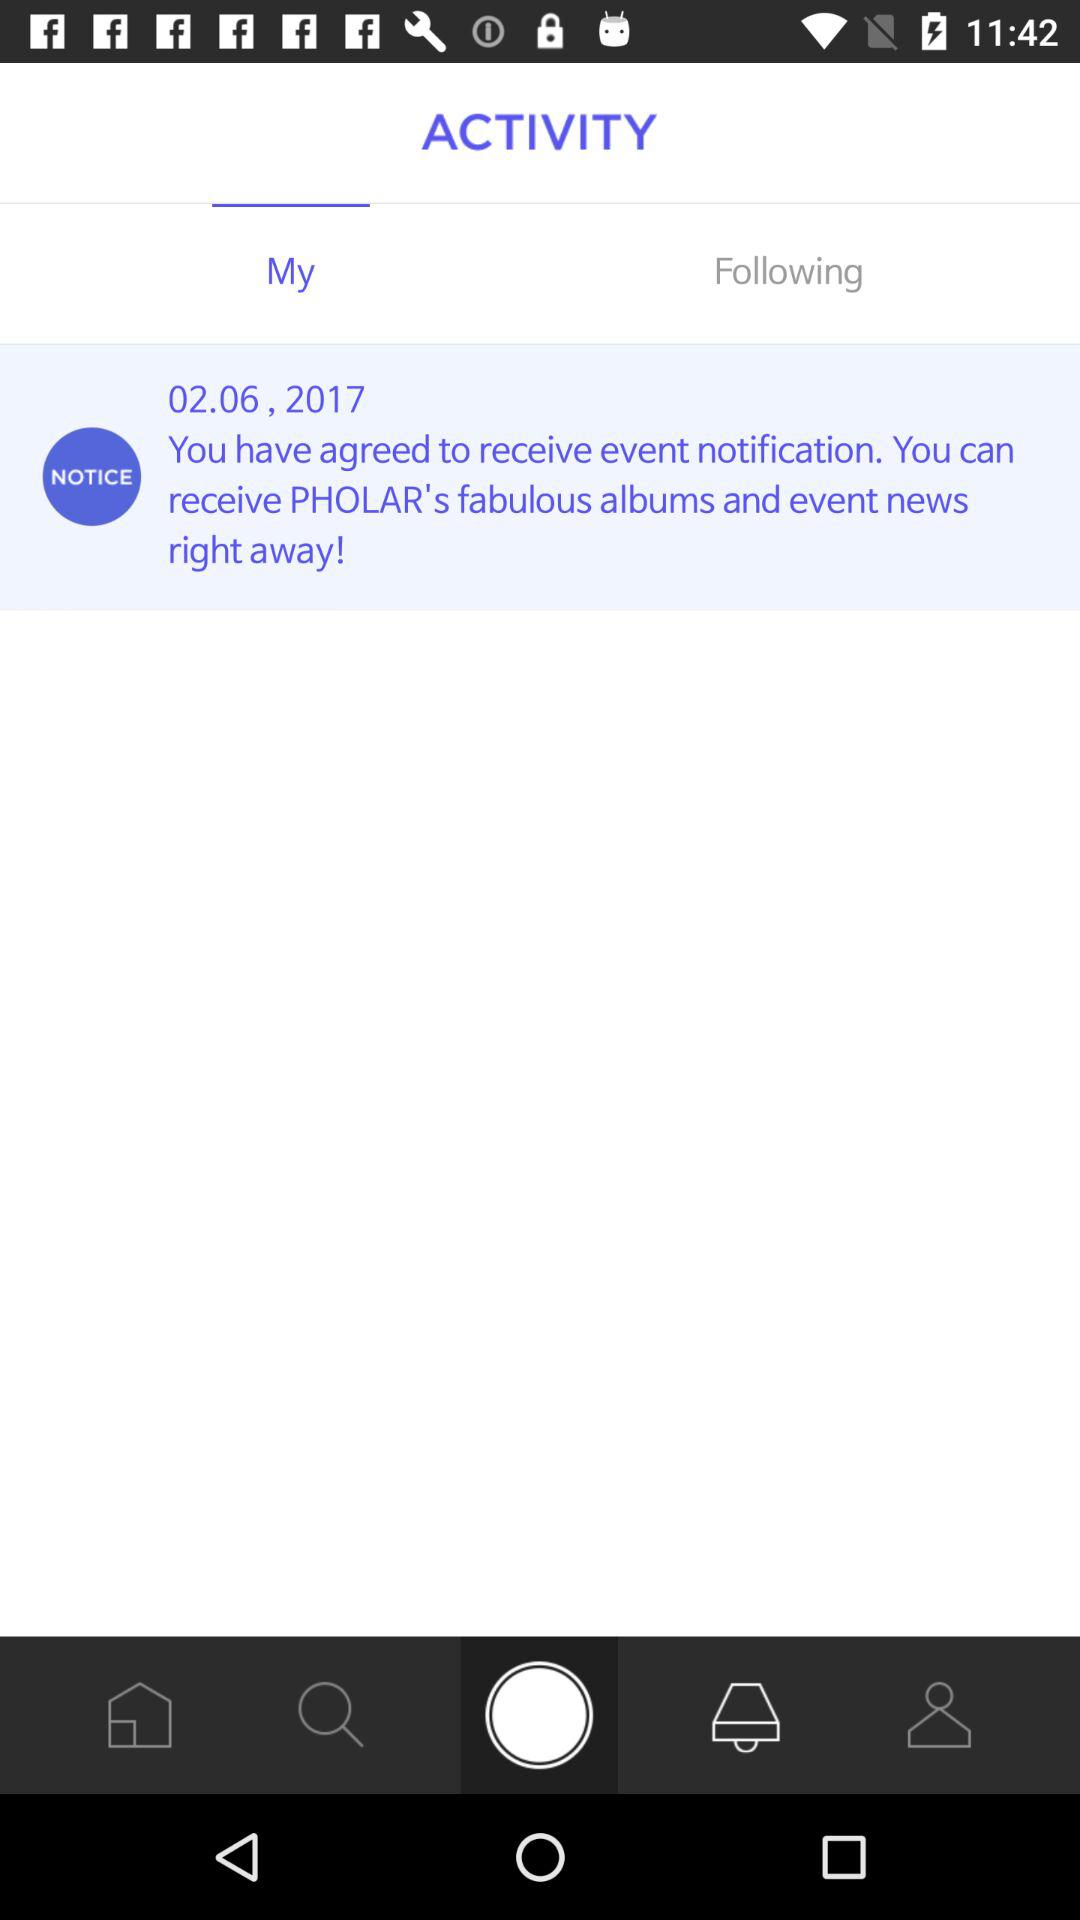What is the given date? The given date is 02.06.2017. 